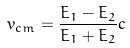<formula> <loc_0><loc_0><loc_500><loc_500>v _ { c m } = \frac { E _ { 1 } - E _ { 2 } } { E _ { 1 } + E _ { 2 } } c</formula> 